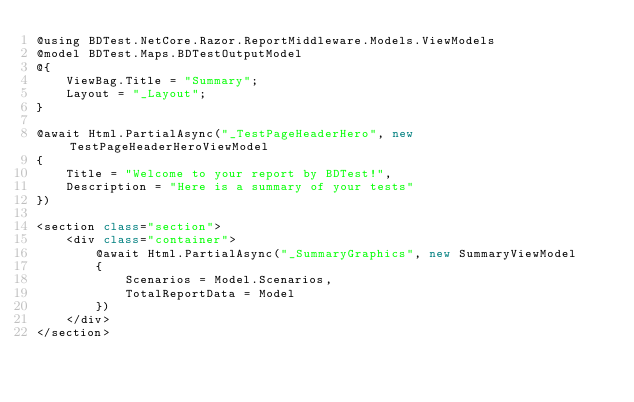<code> <loc_0><loc_0><loc_500><loc_500><_C#_>@using BDTest.NetCore.Razor.ReportMiddleware.Models.ViewModels
@model BDTest.Maps.BDTestOutputModel
@{
    ViewBag.Title = "Summary";
    Layout = "_Layout";
}

@await Html.PartialAsync("_TestPageHeaderHero", new TestPageHeaderHeroViewModel
{
    Title = "Welcome to your report by BDTest!",
    Description = "Here is a summary of your tests"
})

<section class="section">
    <div class="container">
        @await Html.PartialAsync("_SummaryGraphics", new SummaryViewModel
        {
            Scenarios = Model.Scenarios,
            TotalReportData = Model
        })
    </div>
</section></code> 